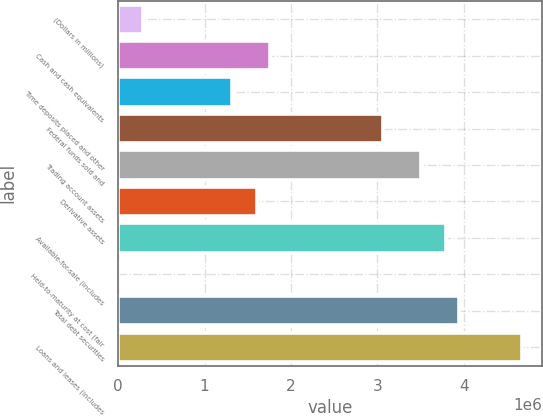<chart> <loc_0><loc_0><loc_500><loc_500><bar_chart><fcel>(Dollars in millions)<fcel>Cash and cash equivalents<fcel>Time deposits placed and other<fcel>Federal funds sold and<fcel>Trading account assets<fcel>Derivative assets<fcel>Available-for-sale (includes<fcel>Held-to-maturity at cost (fair<fcel>Total debt securities<fcel>Loans and leases (includes<nl><fcel>291979<fcel>1.75168e+06<fcel>1.31377e+06<fcel>3.0654e+06<fcel>3.50331e+06<fcel>1.60571e+06<fcel>3.79525e+06<fcel>40<fcel>3.94122e+06<fcel>4.67107e+06<nl></chart> 